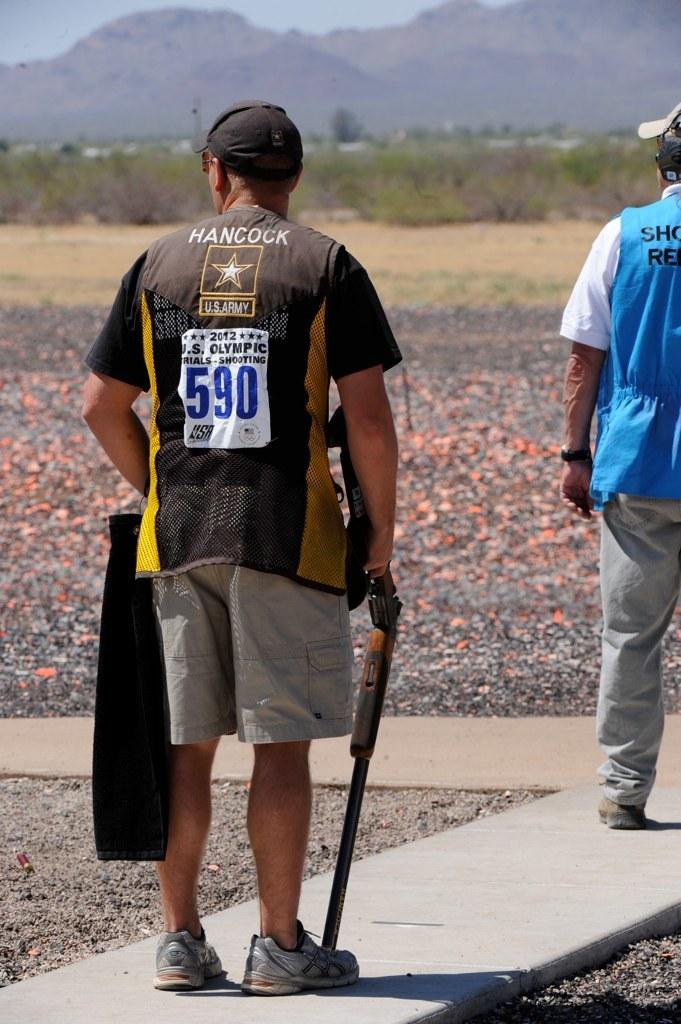<image>
Describe the image concisely. man with rifle barrel on his foot wearing vest showing he is number 590 for 2012 us olympic trials in shooting 